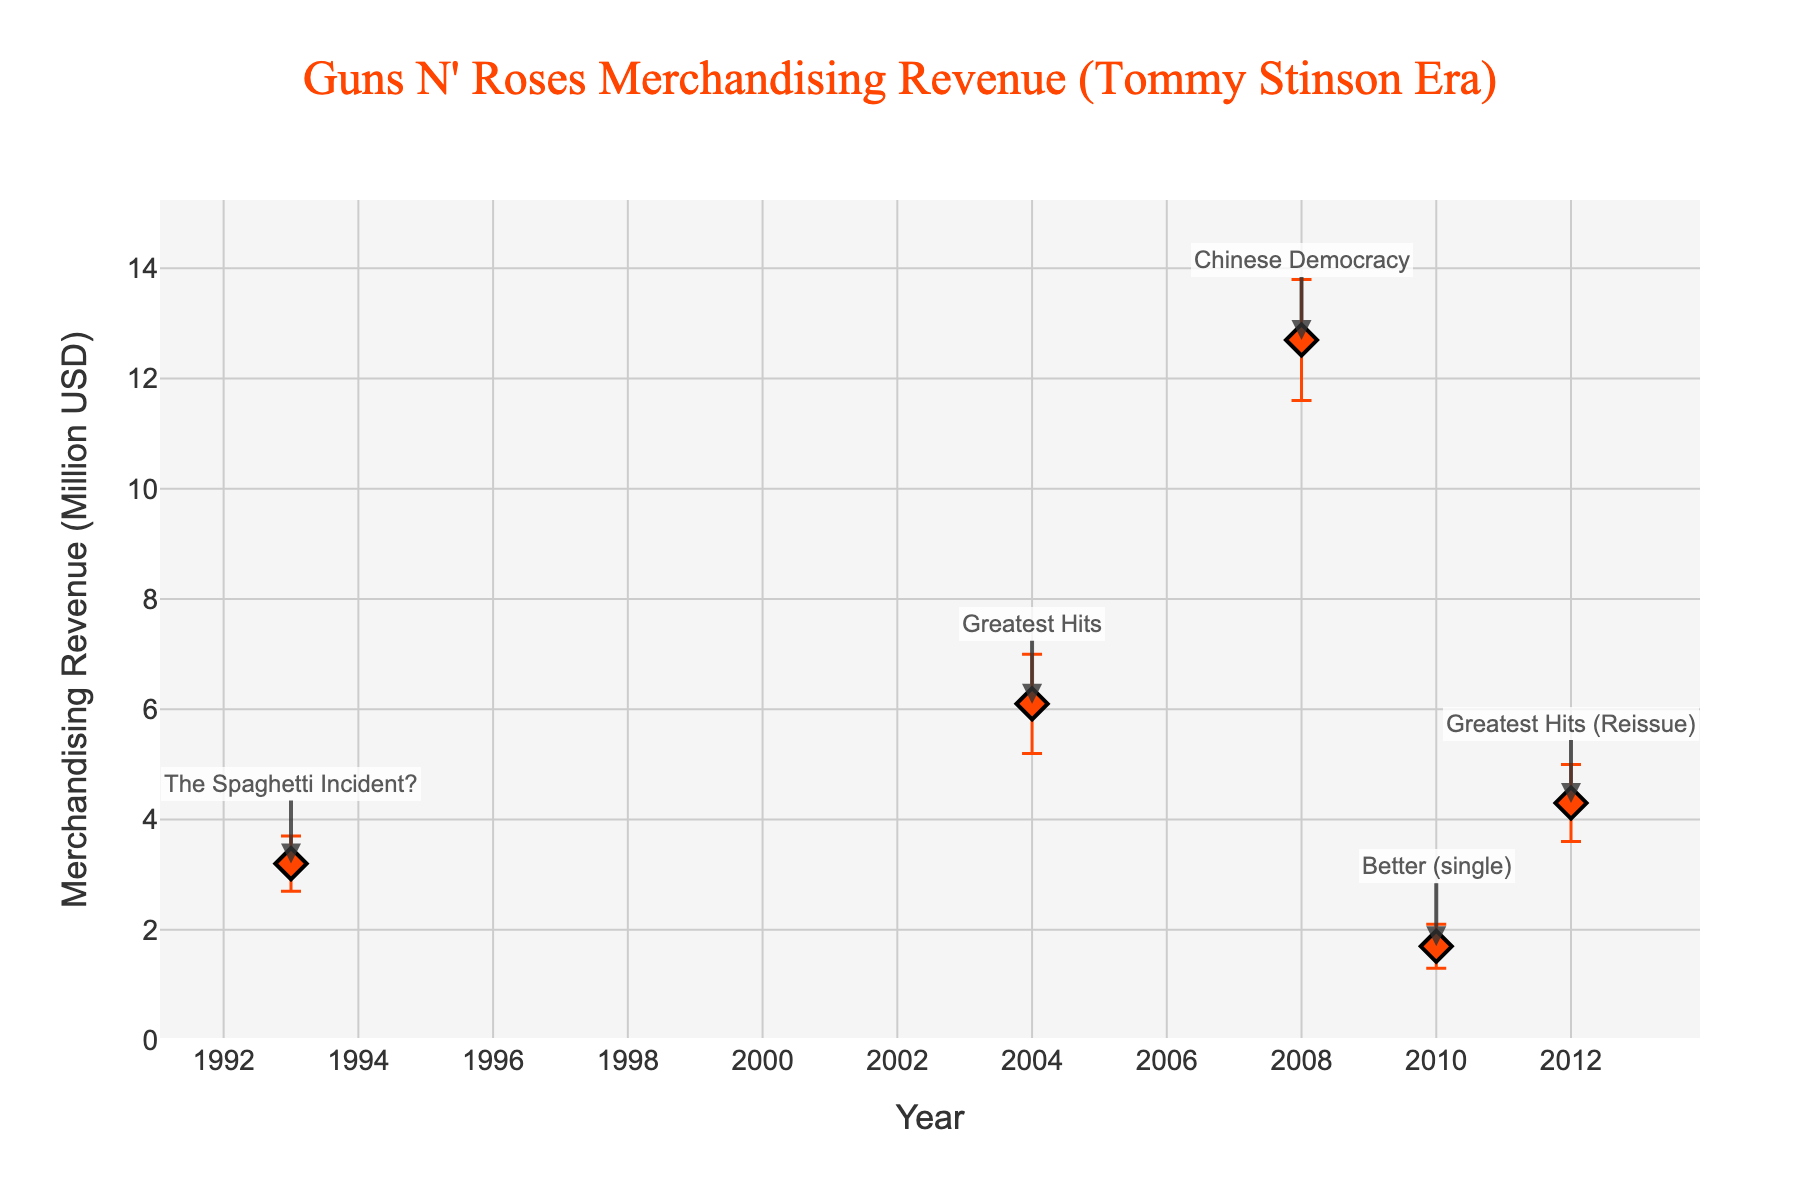What is the title of the figure? The title is displayed at the top of the figure, the text reads, "Guns N' Roses Merchandising Revenue (Tommy Stinson Era)."
Answer: Guns N' Roses Merchandising Revenue (Tommy Stinson Era) How many albums are shown in the figure? The figure shows markers for each album along the plot. Counting the markers, there are 5 in total.
Answer: 5 Which album has the highest merchandising revenue? By looking at the y-axis values for each album and finding the highest point, "Chinese Democracy" has the highest revenue at 12.7 million USD.
Answer: Chinese Democracy What is the revenue of "The Spaghetti Incident?" album? The dot corresponding to the 1993 year is labeled "The Spaghetti Incident?" and its y-value shows the revenue as 3.2 million USD.
Answer: 3.2 million USD Which album has the second lowest revenue, and what is its value? Ordering the y-values from lowest to highest: 1.7 ("Better (single)"), 3.2 ("The Spaghetti Incident?"), 4.3 ("Greatest Hits (Reissue)"), 6.1 ("Greatest Hits"), and 12.7 ("Chinese Democracy"), "The Spaghetti Incident?" is the second lowest at 3.2 million USD.
Answer: The Spaghetti Incident?, 3.2 million USD What is the average revenue of all albums? Adding the revenues of all albums 3.2 + 6.1 + 12.7 + 1.7 + 4.3 and dividing by the total number of albums 5 gives the average (28 / 5 = 5.6).
Answer: 5.6 million USD Which album has the largest standard deviation in revenue? Observing the error bars representing the standard deviations, "Chinese Democracy" has the largest deviation with a value of 1.1 million USD.
Answer: Chinese Democracy How does the revenue of "Greatest Hits (Reissue)" compare to "Greatest Hits"? The revenue for "Greatest Hits" is 6.1 million USD and "Greatest Hits (Reissue)" is 4.3 million USD. "Greatest Hits" has a higher revenue than "Greatest Hits (Reissue)" by 1.8 million USD.
Answer: Greatest Hits has 1.8 million USD more than Greatest Hits (Reissue) What is the range (difference between highest and lowest revenues) of merchandising revenues displayed? Subtract the lowest revenue (1.7 million USD for "Better (single)") from the highest revenue (12.7 million USD for "Chinese Democracy") resulting in a range (12.7 - 1.7 = 11).
Answer: 11 million USD Which album in the figure has the year 2010 and what is its revenue? Looking at the x-axis for 2010, it corresponds to "Better (single)" and the y-value indicates its revenue as 1.7 million USD.
Answer: Better (single), 1.7 million USD 